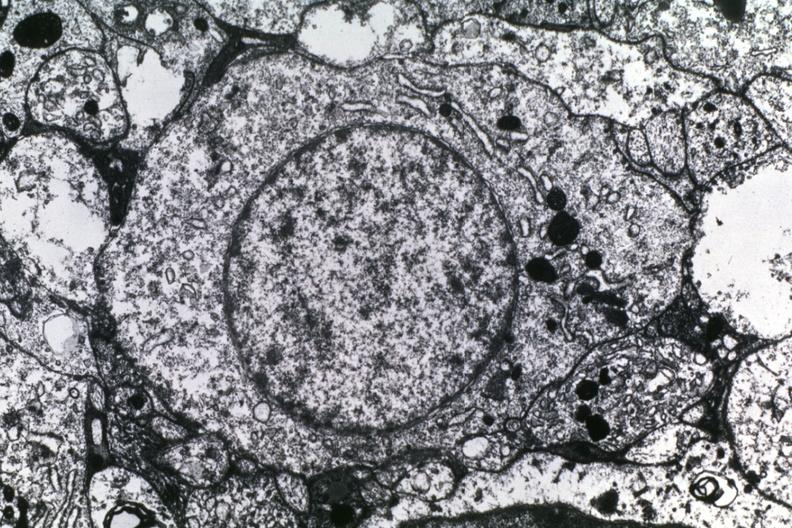s breast present?
Answer the question using a single word or phrase. No 